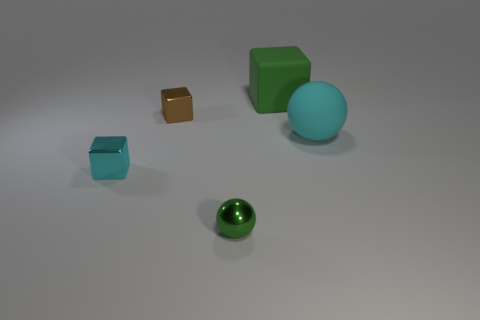What size is the cyan object on the right side of the green shiny ball?
Give a very brief answer. Large. Is the color of the large block the same as the rubber sphere?
Keep it short and to the point. No. Are there any other things that are the same shape as the big cyan matte thing?
Your answer should be very brief. Yes. What material is the block that is the same color as the tiny metal sphere?
Ensure brevity in your answer.  Rubber. Is the number of small brown metal blocks that are right of the green metallic ball the same as the number of large yellow spheres?
Ensure brevity in your answer.  Yes. Are there any green matte cubes in front of the big cyan sphere?
Provide a short and direct response. No. Do the tiny green object and the large thing to the right of the big green block have the same shape?
Your answer should be very brief. Yes. What color is the tiny ball that is made of the same material as the cyan cube?
Your answer should be compact. Green. What is the color of the small shiny sphere?
Offer a very short reply. Green. Are the tiny green sphere and the cyan thing that is left of the big ball made of the same material?
Offer a terse response. Yes. 